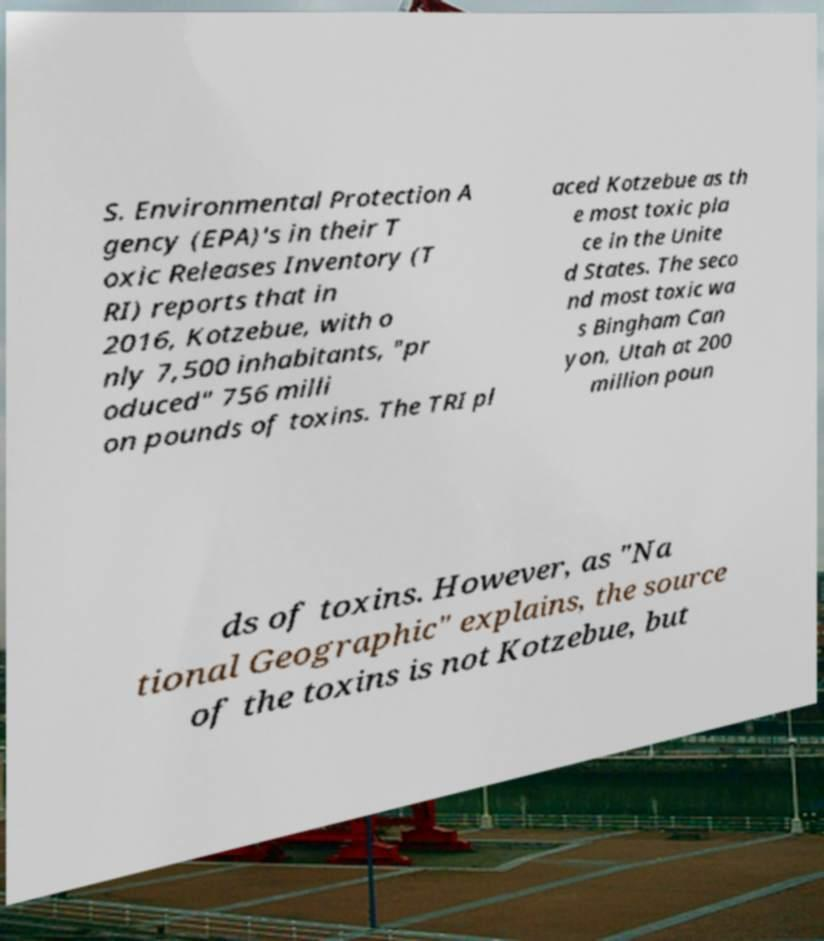There's text embedded in this image that I need extracted. Can you transcribe it verbatim? S. Environmental Protection A gency (EPA)'s in their T oxic Releases Inventory (T RI) reports that in 2016, Kotzebue, with o nly 7,500 inhabitants, "pr oduced" 756 milli on pounds of toxins. The TRI pl aced Kotzebue as th e most toxic pla ce in the Unite d States. The seco nd most toxic wa s Bingham Can yon, Utah at 200 million poun ds of toxins. However, as "Na tional Geographic" explains, the source of the toxins is not Kotzebue, but 